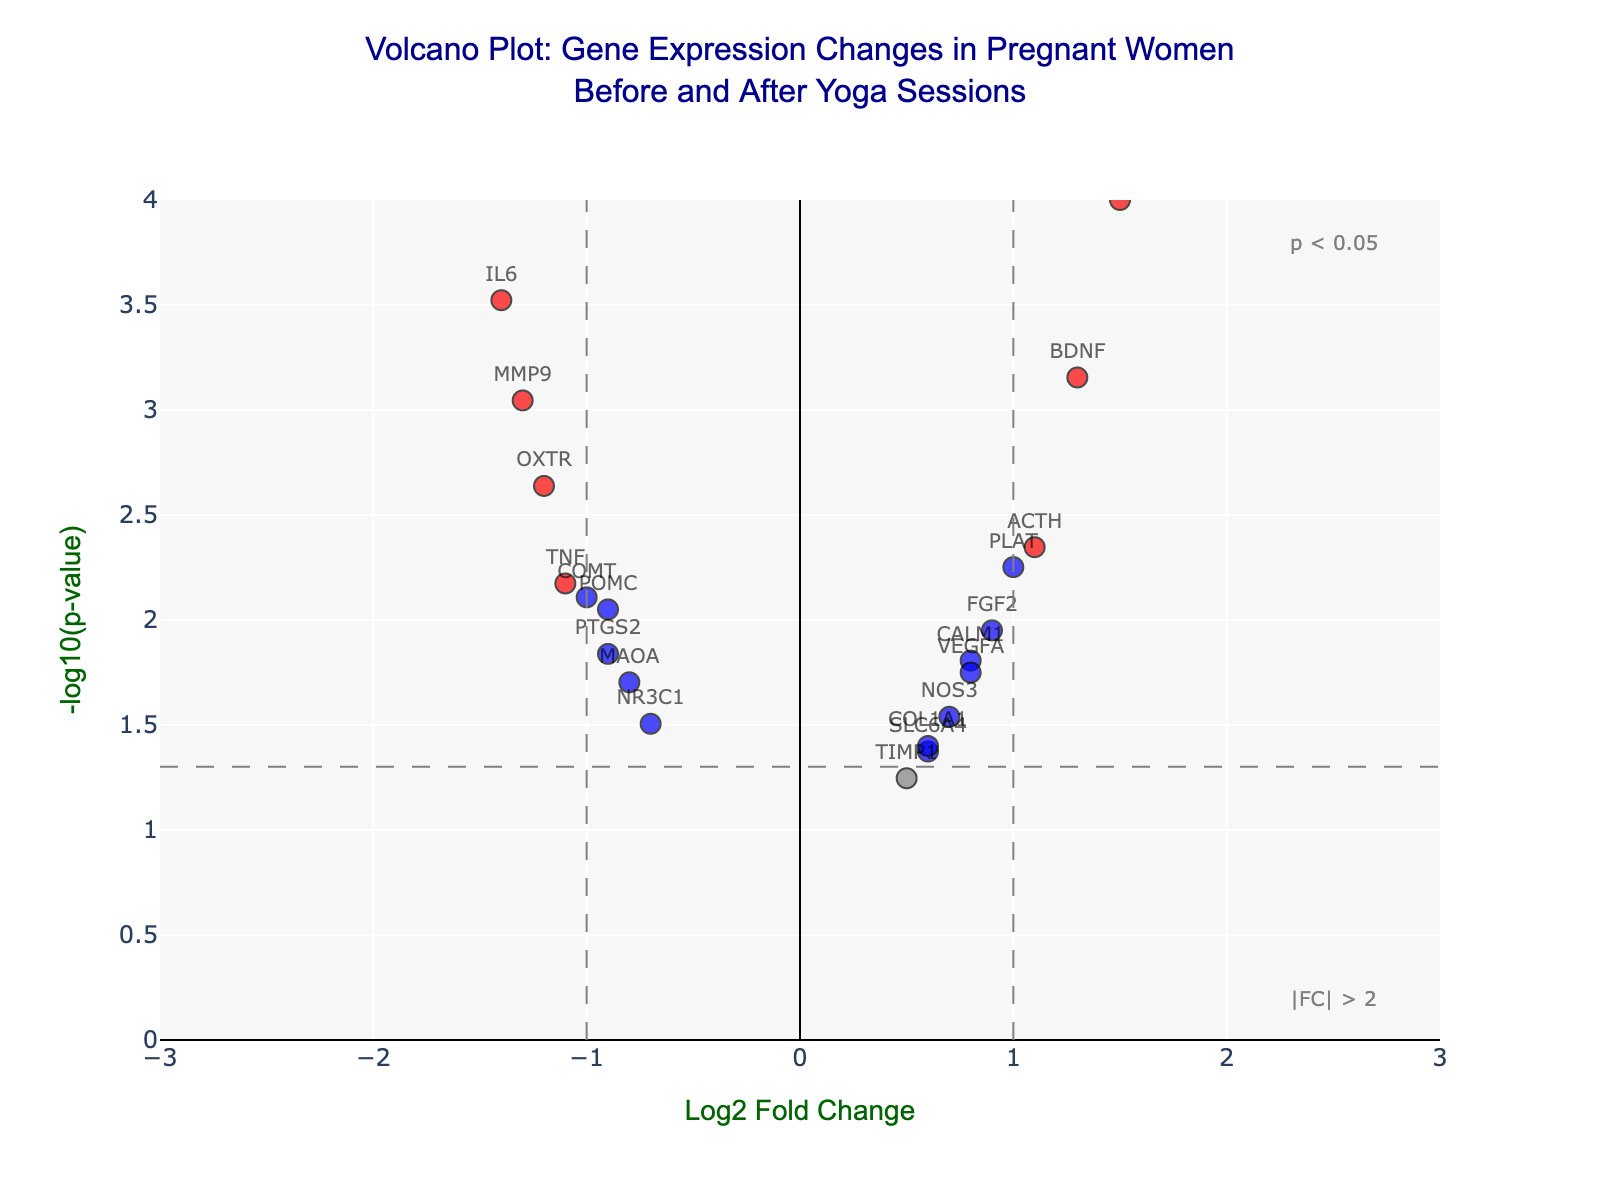What is the title of the volcano plot? The title is located at the top of the figure and reads: "Volcano Plot: Gene Expression Changes in Pregnant Women Before and After Yoga Sessions".
Answer: Volcano Plot: Gene Expression Changes in Pregnant Women Before and After Yoga Sessions How many genes have a log2 fold change greater than 1 and a p-value less than 0.05? To find this, locate data points with a log2 fold change (X-axis) greater than 1 and a -log10(p-value) (Y-axis) higher than the threshold line corresponding to p-value < 0.05. There are three such points.
Answer: 3 Which gene has the most significant p-value and what is its log2 fold change? Identify the point with the highest -log10(p-value). The gene CRH has the highest -log10(p-value) of 4, indicating it has the most significant p-value. Its log2 fold change is 1.5.
Answer: CRH, 1.5 Are there any genes with a log2 fold change less than -1 that are considered significant (p-value < 0.05)? Look for data points on the left side (log2 fold change < -1) and above the significance threshold line. The genes OXTR, IL6, and MMP9 fall into this category.
Answer: Yes, OXTR, IL6, and MMP9 Which gene shows the largest negative log2 fold change and is it significant? Identify the gene with the smallest log2 fold change value. The gene IL6 has the largest negative log2 fold change of -1.4 and is significant as its p-value is less than 0.05.
Answer: IL6, Yes Which gene has the highest -log10(p-value) among those with log2 fold change close to zero (< 0.5)? Locate the data points near the X-axis center (log2 fold change close to zero), and find the tallest point among them. TIMP1 with -log10(p-value) little more than 1.2 is the one.
Answer: TIMP1 How many genes have positive log2 fold changes and significant p-values? Count the data points that are on the right of the Y-axis (positive log2 fold change) and above the significance threshold line. There are six such points.
Answer: 6 Are there any genes with a log2 fold change exactly equal to 1? Examine the plot to find any point with a log2 fold change value of exactly 1. The gene PLAT has a log2 fold change of 1.0.
Answer: Yes, PLAT 